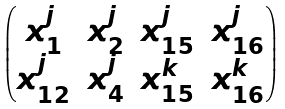<formula> <loc_0><loc_0><loc_500><loc_500>\begin{pmatrix} x _ { 1 } ^ { j } & x _ { 2 } ^ { j } & x _ { 1 5 } ^ { j } & x _ { 1 6 } ^ { j } \\ x _ { 1 2 } ^ { j } & x _ { 4 } ^ { j } & x _ { 1 5 } ^ { k } & x _ { 1 6 } ^ { k } \end{pmatrix}</formula> 